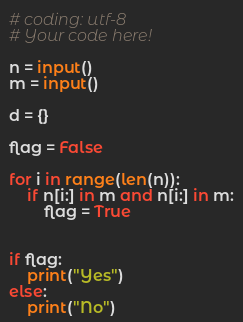Convert code to text. <code><loc_0><loc_0><loc_500><loc_500><_Python_># coding: utf-8
# Your code here!

n = input()
m = input()

d = {}

flag = False

for i in range(len(n)):
    if n[i:] in m and n[i:] in m:
        flag = True
        
        
if flag:
    print("Yes")
else:
    print("No")</code> 